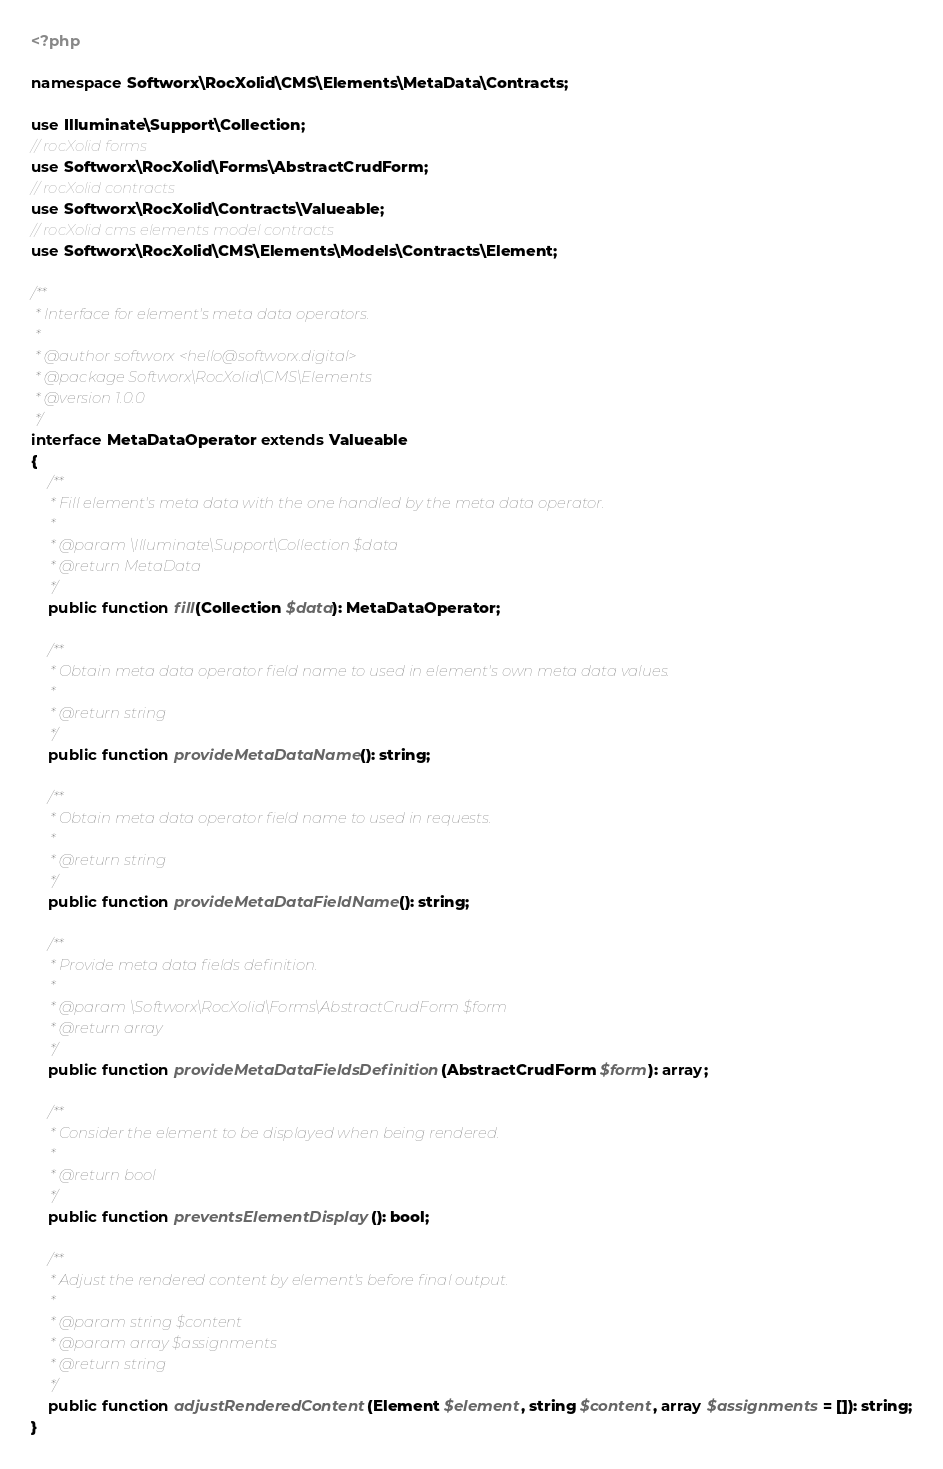<code> <loc_0><loc_0><loc_500><loc_500><_PHP_><?php

namespace Softworx\RocXolid\CMS\Elements\MetaData\Contracts;

use Illuminate\Support\Collection;
// rocXolid forms
use Softworx\RocXolid\Forms\AbstractCrudForm;
// rocXolid contracts
use Softworx\RocXolid\Contracts\Valueable;
// rocXolid cms elements model contracts
use Softworx\RocXolid\CMS\Elements\Models\Contracts\Element;

/**
 * Interface for element's meta data operators.
 *
 * @author softworx <hello@softworx.digital>
 * @package Softworx\RocXolid\CMS\Elements
 * @version 1.0.0
 */
interface MetaDataOperator extends Valueable
{
    /**
     * Fill element's meta data with the one handled by the meta data operator.
     *
     * @param \Illuminate\Support\Collection $data
     * @return MetaData
     */
    public function fill(Collection $data): MetaDataOperator;

    /**
     * Obtain meta data operator field name to used in element's own meta data values.
     *
     * @return string
     */
    public function provideMetaDataName(): string;

    /**
     * Obtain meta data operator field name to used in requests.
     *
     * @return string
     */
    public function provideMetaDataFieldName(): string;

    /**
     * Provide meta data fields definition.
     *
     * @param \Softworx\RocXolid\Forms\AbstractCrudForm $form
     * @return array
     */
    public function provideMetaDataFieldsDefinition(AbstractCrudForm $form): array;

    /**
     * Consider the element to be displayed when being rendered.
     *
     * @return bool
     */
    public function preventsElementDisplay(): bool;

    /**
     * Adjust the rendered content by element's before final output.
     *
     * @param string $content
     * @param array $assignments
     * @return string
     */
    public function adjustRenderedContent(Element $element, string $content, array $assignments = []): string;
}
</code> 